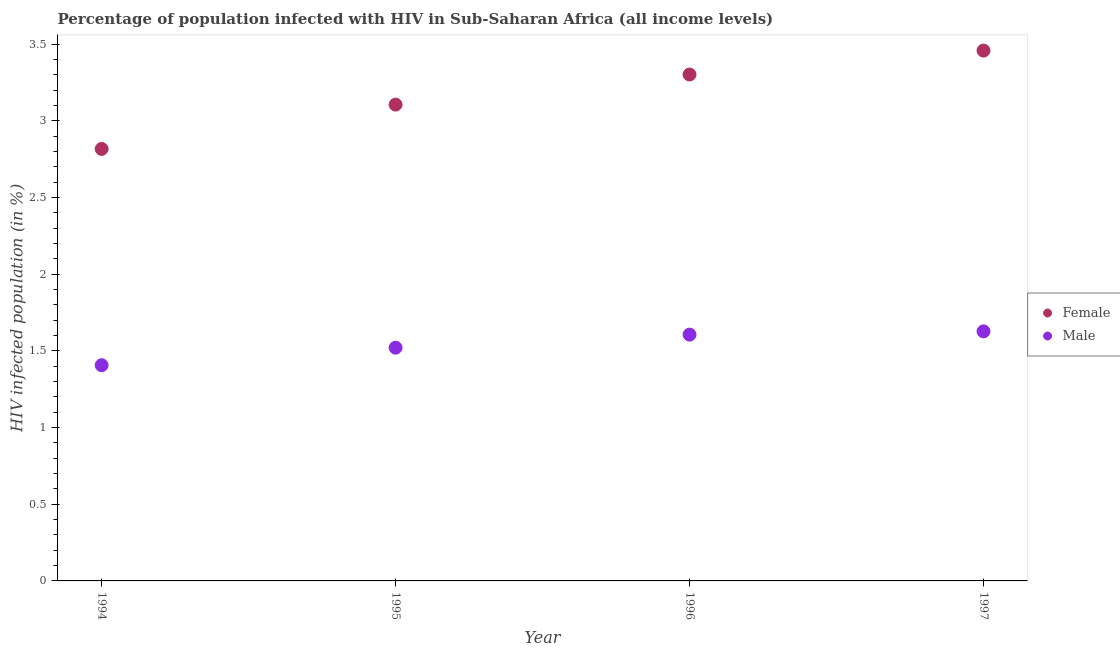Is the number of dotlines equal to the number of legend labels?
Provide a short and direct response. Yes. What is the percentage of males who are infected with hiv in 1996?
Your response must be concise. 1.61. Across all years, what is the maximum percentage of females who are infected with hiv?
Your answer should be very brief. 3.46. Across all years, what is the minimum percentage of females who are infected with hiv?
Ensure brevity in your answer.  2.82. In which year was the percentage of females who are infected with hiv minimum?
Keep it short and to the point. 1994. What is the total percentage of females who are infected with hiv in the graph?
Give a very brief answer. 12.69. What is the difference between the percentage of females who are infected with hiv in 1994 and that in 1996?
Give a very brief answer. -0.49. What is the difference between the percentage of males who are infected with hiv in 1996 and the percentage of females who are infected with hiv in 1995?
Provide a succinct answer. -1.5. What is the average percentage of males who are infected with hiv per year?
Ensure brevity in your answer.  1.54. In the year 1996, what is the difference between the percentage of males who are infected with hiv and percentage of females who are infected with hiv?
Your answer should be very brief. -1.7. In how many years, is the percentage of females who are infected with hiv greater than 0.5 %?
Give a very brief answer. 4. What is the ratio of the percentage of males who are infected with hiv in 1994 to that in 1997?
Offer a terse response. 0.86. What is the difference between the highest and the second highest percentage of males who are infected with hiv?
Offer a terse response. 0.02. What is the difference between the highest and the lowest percentage of males who are infected with hiv?
Ensure brevity in your answer.  0.22. In how many years, is the percentage of females who are infected with hiv greater than the average percentage of females who are infected with hiv taken over all years?
Your answer should be very brief. 2. Is the sum of the percentage of females who are infected with hiv in 1995 and 1997 greater than the maximum percentage of males who are infected with hiv across all years?
Provide a short and direct response. Yes. Does the percentage of females who are infected with hiv monotonically increase over the years?
Ensure brevity in your answer.  Yes. Is the percentage of males who are infected with hiv strictly greater than the percentage of females who are infected with hiv over the years?
Your response must be concise. No. Is the percentage of females who are infected with hiv strictly less than the percentage of males who are infected with hiv over the years?
Offer a very short reply. No. How many dotlines are there?
Ensure brevity in your answer.  2. Are the values on the major ticks of Y-axis written in scientific E-notation?
Offer a terse response. No. Does the graph contain any zero values?
Give a very brief answer. No. Where does the legend appear in the graph?
Your answer should be compact. Center right. What is the title of the graph?
Your response must be concise. Percentage of population infected with HIV in Sub-Saharan Africa (all income levels). Does "Netherlands" appear as one of the legend labels in the graph?
Keep it short and to the point. No. What is the label or title of the Y-axis?
Offer a very short reply. HIV infected population (in %). What is the HIV infected population (in %) of Female in 1994?
Make the answer very short. 2.82. What is the HIV infected population (in %) in Male in 1994?
Make the answer very short. 1.41. What is the HIV infected population (in %) of Female in 1995?
Give a very brief answer. 3.11. What is the HIV infected population (in %) of Male in 1995?
Your answer should be compact. 1.52. What is the HIV infected population (in %) of Female in 1996?
Provide a short and direct response. 3.3. What is the HIV infected population (in %) of Male in 1996?
Give a very brief answer. 1.61. What is the HIV infected population (in %) in Female in 1997?
Offer a very short reply. 3.46. What is the HIV infected population (in %) of Male in 1997?
Make the answer very short. 1.63. Across all years, what is the maximum HIV infected population (in %) of Female?
Your response must be concise. 3.46. Across all years, what is the maximum HIV infected population (in %) of Male?
Ensure brevity in your answer.  1.63. Across all years, what is the minimum HIV infected population (in %) of Female?
Ensure brevity in your answer.  2.82. Across all years, what is the minimum HIV infected population (in %) of Male?
Keep it short and to the point. 1.41. What is the total HIV infected population (in %) in Female in the graph?
Provide a succinct answer. 12.69. What is the total HIV infected population (in %) of Male in the graph?
Your answer should be very brief. 6.16. What is the difference between the HIV infected population (in %) of Female in 1994 and that in 1995?
Provide a succinct answer. -0.29. What is the difference between the HIV infected population (in %) in Male in 1994 and that in 1995?
Your answer should be compact. -0.11. What is the difference between the HIV infected population (in %) of Female in 1994 and that in 1996?
Keep it short and to the point. -0.49. What is the difference between the HIV infected population (in %) in Male in 1994 and that in 1996?
Make the answer very short. -0.2. What is the difference between the HIV infected population (in %) in Female in 1994 and that in 1997?
Provide a short and direct response. -0.64. What is the difference between the HIV infected population (in %) of Male in 1994 and that in 1997?
Provide a short and direct response. -0.22. What is the difference between the HIV infected population (in %) in Female in 1995 and that in 1996?
Provide a succinct answer. -0.2. What is the difference between the HIV infected population (in %) in Male in 1995 and that in 1996?
Give a very brief answer. -0.09. What is the difference between the HIV infected population (in %) in Female in 1995 and that in 1997?
Your answer should be compact. -0.35. What is the difference between the HIV infected population (in %) of Male in 1995 and that in 1997?
Keep it short and to the point. -0.11. What is the difference between the HIV infected population (in %) in Female in 1996 and that in 1997?
Your response must be concise. -0.16. What is the difference between the HIV infected population (in %) of Male in 1996 and that in 1997?
Keep it short and to the point. -0.02. What is the difference between the HIV infected population (in %) of Female in 1994 and the HIV infected population (in %) of Male in 1995?
Offer a very short reply. 1.3. What is the difference between the HIV infected population (in %) of Female in 1994 and the HIV infected population (in %) of Male in 1996?
Make the answer very short. 1.21. What is the difference between the HIV infected population (in %) in Female in 1994 and the HIV infected population (in %) in Male in 1997?
Give a very brief answer. 1.19. What is the difference between the HIV infected population (in %) in Female in 1995 and the HIV infected population (in %) in Male in 1996?
Ensure brevity in your answer.  1.5. What is the difference between the HIV infected population (in %) in Female in 1995 and the HIV infected population (in %) in Male in 1997?
Provide a short and direct response. 1.48. What is the difference between the HIV infected population (in %) in Female in 1996 and the HIV infected population (in %) in Male in 1997?
Offer a terse response. 1.68. What is the average HIV infected population (in %) in Female per year?
Provide a succinct answer. 3.17. What is the average HIV infected population (in %) in Male per year?
Ensure brevity in your answer.  1.54. In the year 1994, what is the difference between the HIV infected population (in %) of Female and HIV infected population (in %) of Male?
Your answer should be compact. 1.41. In the year 1995, what is the difference between the HIV infected population (in %) in Female and HIV infected population (in %) in Male?
Your answer should be very brief. 1.59. In the year 1996, what is the difference between the HIV infected population (in %) of Female and HIV infected population (in %) of Male?
Your answer should be compact. 1.7. In the year 1997, what is the difference between the HIV infected population (in %) of Female and HIV infected population (in %) of Male?
Give a very brief answer. 1.83. What is the ratio of the HIV infected population (in %) in Female in 1994 to that in 1995?
Make the answer very short. 0.91. What is the ratio of the HIV infected population (in %) of Male in 1994 to that in 1995?
Make the answer very short. 0.92. What is the ratio of the HIV infected population (in %) in Female in 1994 to that in 1996?
Your answer should be very brief. 0.85. What is the ratio of the HIV infected population (in %) in Male in 1994 to that in 1996?
Offer a terse response. 0.88. What is the ratio of the HIV infected population (in %) of Female in 1994 to that in 1997?
Provide a succinct answer. 0.81. What is the ratio of the HIV infected population (in %) in Male in 1994 to that in 1997?
Keep it short and to the point. 0.86. What is the ratio of the HIV infected population (in %) of Female in 1995 to that in 1996?
Your answer should be compact. 0.94. What is the ratio of the HIV infected population (in %) of Male in 1995 to that in 1996?
Your answer should be compact. 0.95. What is the ratio of the HIV infected population (in %) in Female in 1995 to that in 1997?
Keep it short and to the point. 0.9. What is the ratio of the HIV infected population (in %) in Male in 1995 to that in 1997?
Offer a terse response. 0.93. What is the ratio of the HIV infected population (in %) of Female in 1996 to that in 1997?
Keep it short and to the point. 0.95. What is the ratio of the HIV infected population (in %) of Male in 1996 to that in 1997?
Your answer should be very brief. 0.99. What is the difference between the highest and the second highest HIV infected population (in %) in Female?
Give a very brief answer. 0.16. What is the difference between the highest and the second highest HIV infected population (in %) of Male?
Your answer should be compact. 0.02. What is the difference between the highest and the lowest HIV infected population (in %) in Female?
Offer a very short reply. 0.64. What is the difference between the highest and the lowest HIV infected population (in %) in Male?
Your answer should be compact. 0.22. 